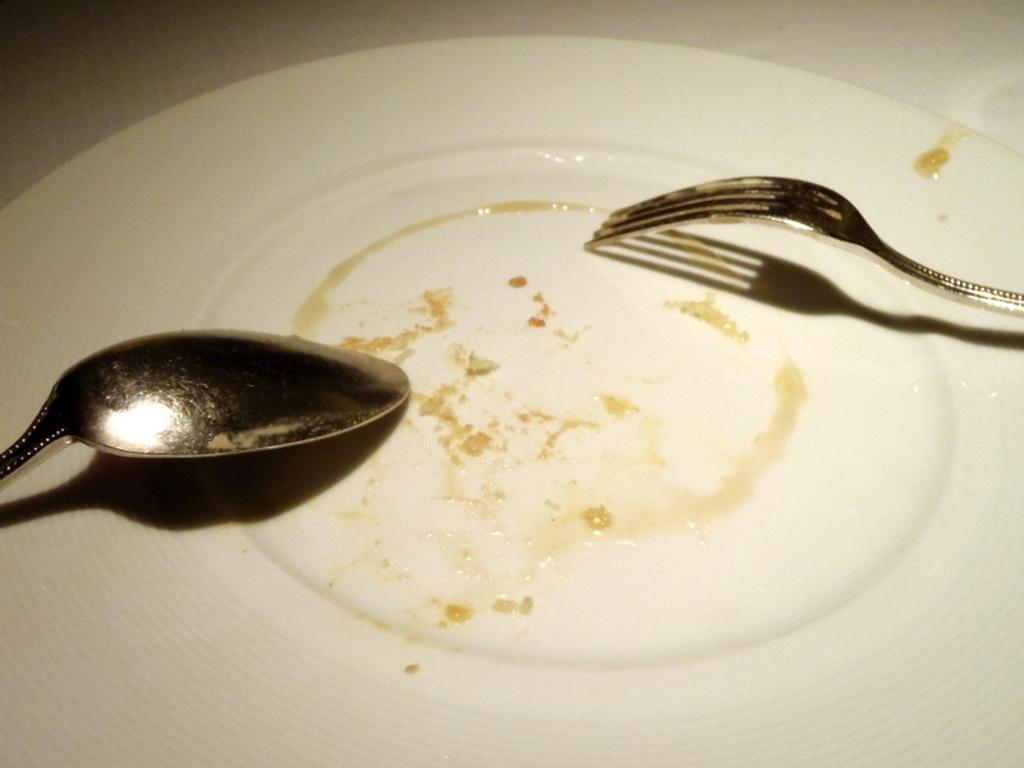What is present on the plate in the image? The facts provided do not specify what is on the plate. What utensil is visible in the image? There is a spoon and a fork in the image. What can be used for cleaning or wiping in the image? Tissue paper is visible in the image. What type of attraction is present in the image? There is no attraction present in the image; it only contains a plate, spoon, fork, and tissue paper. How does the game in the image affect the throat? There is no game present in the image, and therefore it cannot affect the throat. 